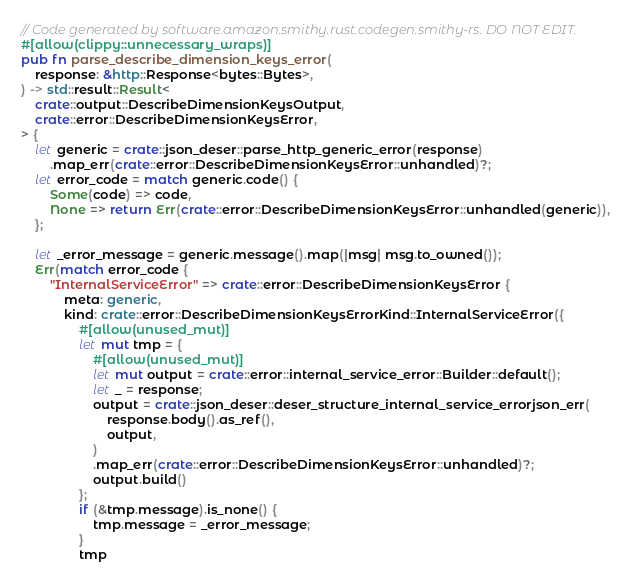Convert code to text. <code><loc_0><loc_0><loc_500><loc_500><_Rust_>// Code generated by software.amazon.smithy.rust.codegen.smithy-rs. DO NOT EDIT.
#[allow(clippy::unnecessary_wraps)]
pub fn parse_describe_dimension_keys_error(
    response: &http::Response<bytes::Bytes>,
) -> std::result::Result<
    crate::output::DescribeDimensionKeysOutput,
    crate::error::DescribeDimensionKeysError,
> {
    let generic = crate::json_deser::parse_http_generic_error(response)
        .map_err(crate::error::DescribeDimensionKeysError::unhandled)?;
    let error_code = match generic.code() {
        Some(code) => code,
        None => return Err(crate::error::DescribeDimensionKeysError::unhandled(generic)),
    };

    let _error_message = generic.message().map(|msg| msg.to_owned());
    Err(match error_code {
        "InternalServiceError" => crate::error::DescribeDimensionKeysError {
            meta: generic,
            kind: crate::error::DescribeDimensionKeysErrorKind::InternalServiceError({
                #[allow(unused_mut)]
                let mut tmp = {
                    #[allow(unused_mut)]
                    let mut output = crate::error::internal_service_error::Builder::default();
                    let _ = response;
                    output = crate::json_deser::deser_structure_internal_service_errorjson_err(
                        response.body().as_ref(),
                        output,
                    )
                    .map_err(crate::error::DescribeDimensionKeysError::unhandled)?;
                    output.build()
                };
                if (&tmp.message).is_none() {
                    tmp.message = _error_message;
                }
                tmp</code> 